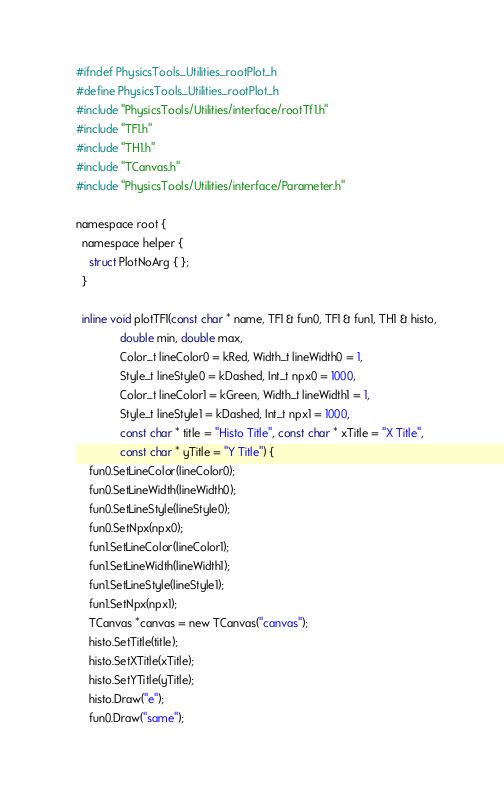Convert code to text. <code><loc_0><loc_0><loc_500><loc_500><_C_>#ifndef PhysicsTools_Utilities_rootPlot_h
#define PhysicsTools_Utilities_rootPlot_h
#include "PhysicsTools/Utilities/interface/rootTf1.h"
#include "TF1.h"
#include "TH1.h"
#include "TCanvas.h"
#include "PhysicsTools/Utilities/interface/Parameter.h"

namespace root {
  namespace helper {
    struct PlotNoArg { };
  }
  
  inline void plotTF1(const char * name, TF1 & fun0, TF1 & fun1, TH1 & histo, 
		      double min, double max,
		      Color_t lineColor0 = kRed, Width_t lineWidth0 = 1,
		      Style_t lineStyle0 = kDashed, Int_t npx0 = 1000, 
		      Color_t lineColor1 = kGreen, Width_t lineWidth1 = 1,
		      Style_t lineStyle1 = kDashed, Int_t npx1 = 1000, 
		      const char * title = "Histo Title", const char * xTitle = "X Title", 
		      const char * yTitle = "Y Title") {
    fun0.SetLineColor(lineColor0);
    fun0.SetLineWidth(lineWidth0);
    fun0.SetLineStyle(lineStyle0);
    fun0.SetNpx(npx0);
    fun1.SetLineColor(lineColor1);
    fun1.SetLineWidth(lineWidth1);
    fun1.SetLineStyle(lineStyle1);
    fun1.SetNpx(npx1);
    TCanvas *canvas = new TCanvas("canvas");
    histo.SetTitle(title);
    histo.SetXTitle(xTitle);
    histo.SetYTitle(yTitle);
    histo.Draw("e");
    fun0.Draw("same");</code> 